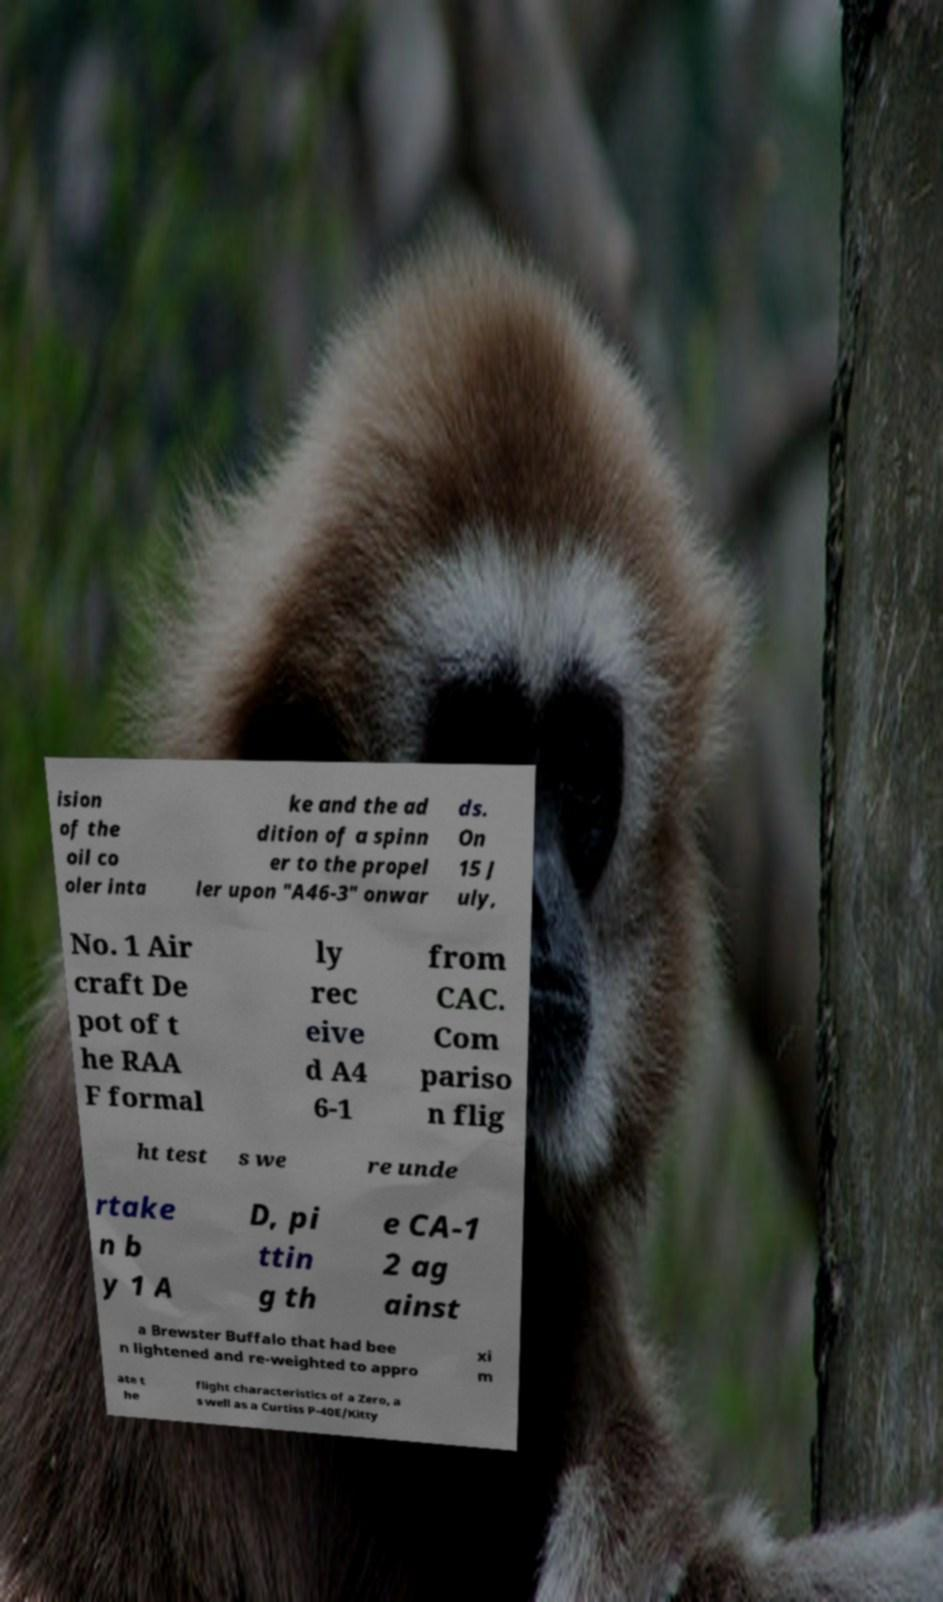Could you extract and type out the text from this image? ision of the oil co oler inta ke and the ad dition of a spinn er to the propel ler upon "A46-3" onwar ds. On 15 J uly, No. 1 Air craft De pot of t he RAA F formal ly rec eive d A4 6-1 from CAC. Com pariso n flig ht test s we re unde rtake n b y 1 A D, pi ttin g th e CA-1 2 ag ainst a Brewster Buffalo that had bee n lightened and re-weighted to appro xi m ate t he flight characteristics of a Zero, a s well as a Curtiss P-40E/Kitty 